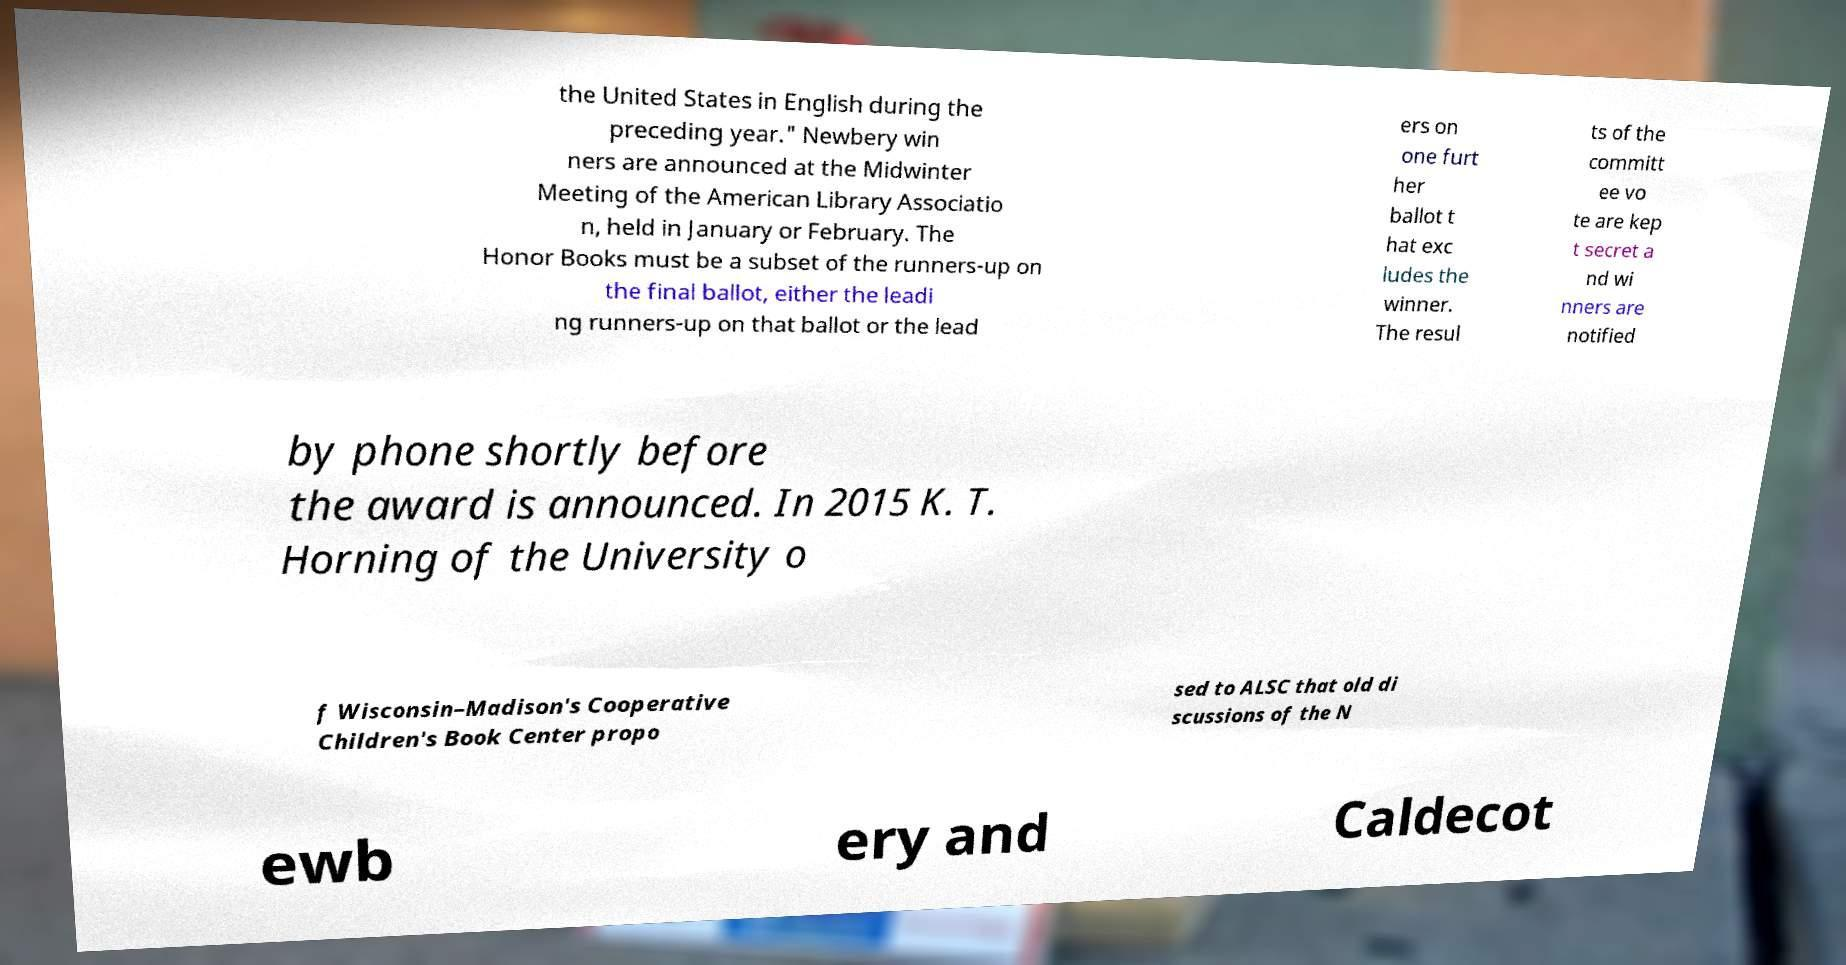Please read and relay the text visible in this image. What does it say? the United States in English during the preceding year." Newbery win ners are announced at the Midwinter Meeting of the American Library Associatio n, held in January or February. The Honor Books must be a subset of the runners-up on the final ballot, either the leadi ng runners-up on that ballot or the lead ers on one furt her ballot t hat exc ludes the winner. The resul ts of the committ ee vo te are kep t secret a nd wi nners are notified by phone shortly before the award is announced. In 2015 K. T. Horning of the University o f Wisconsin–Madison's Cooperative Children's Book Center propo sed to ALSC that old di scussions of the N ewb ery and Caldecot 